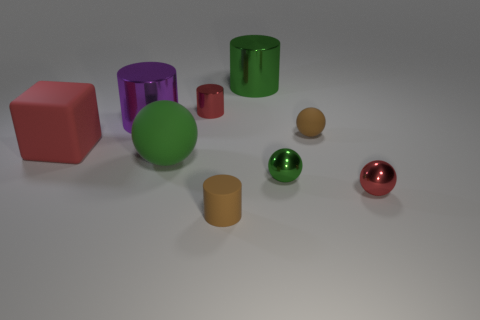Is there a sphere that has the same color as the small matte cylinder?
Your response must be concise. Yes. Are there more brown objects that are to the left of the brown sphere than small purple rubber cylinders?
Give a very brief answer. Yes. There is a red rubber object; does it have the same shape as the small matte object that is to the left of the green metal cylinder?
Your response must be concise. No. Are any blue cylinders visible?
Provide a succinct answer. No. How many big things are blocks or green rubber cubes?
Keep it short and to the point. 1. Are there more metal things in front of the big purple metallic cylinder than red metal balls on the left side of the rubber cylinder?
Ensure brevity in your answer.  Yes. Are the small green object and the brown thing behind the large red block made of the same material?
Keep it short and to the point. No. What is the color of the large ball?
Provide a succinct answer. Green. There is a brown rubber thing that is in front of the large red matte cube; what is its shape?
Your response must be concise. Cylinder. What number of purple things are either small shiny cylinders or big metallic things?
Ensure brevity in your answer.  1. 